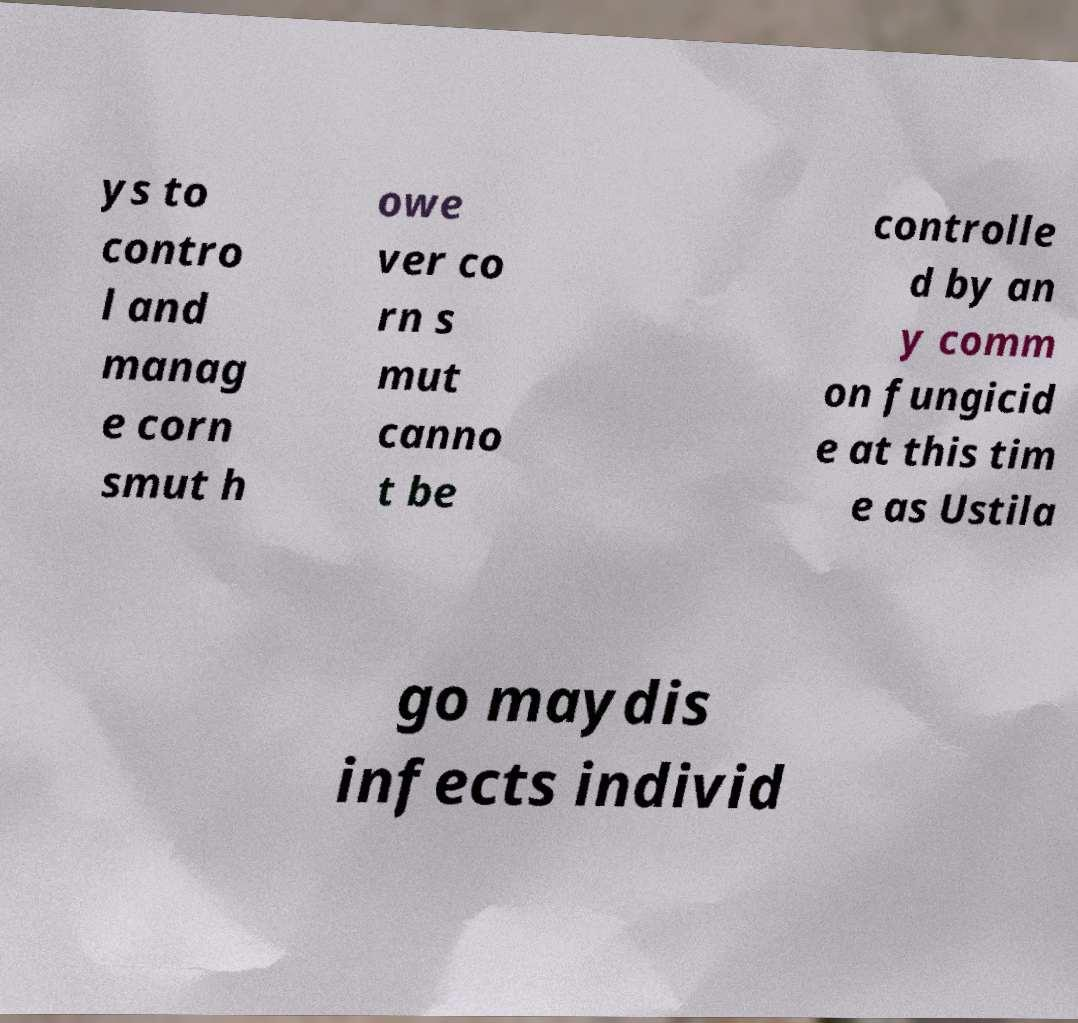Could you assist in decoding the text presented in this image and type it out clearly? ys to contro l and manag e corn smut h owe ver co rn s mut canno t be controlle d by an y comm on fungicid e at this tim e as Ustila go maydis infects individ 